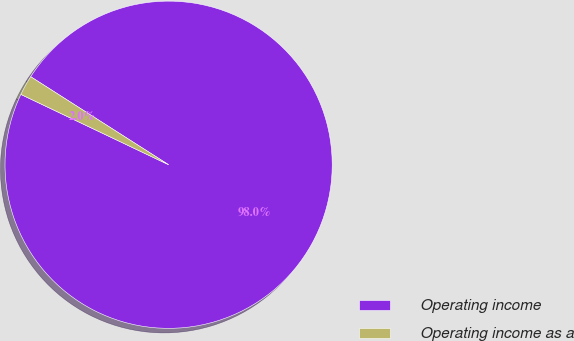<chart> <loc_0><loc_0><loc_500><loc_500><pie_chart><fcel>Operating income<fcel>Operating income as a<nl><fcel>98.03%<fcel>1.97%<nl></chart> 